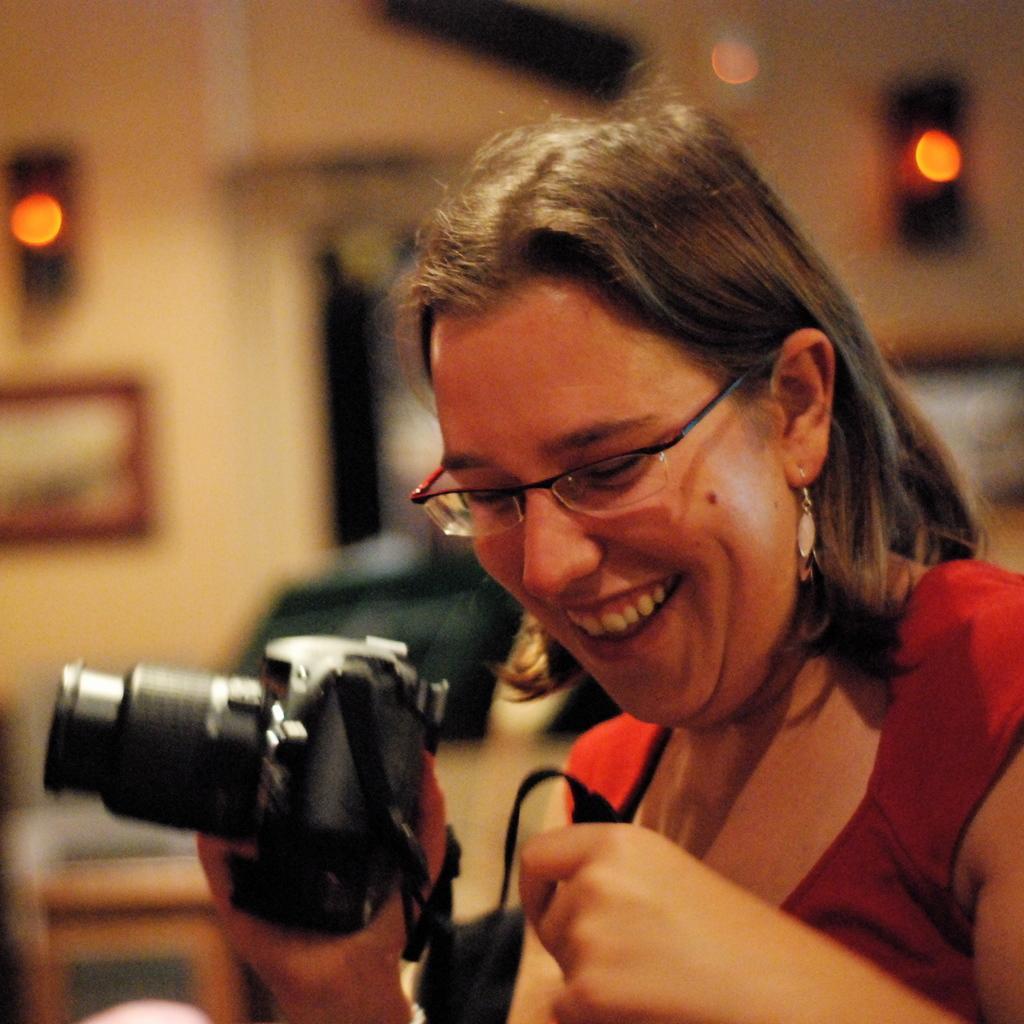Describe this image in one or two sentences. As we can see in the image in the front there is a woman holding camera. In the background there is a wall and lights. 